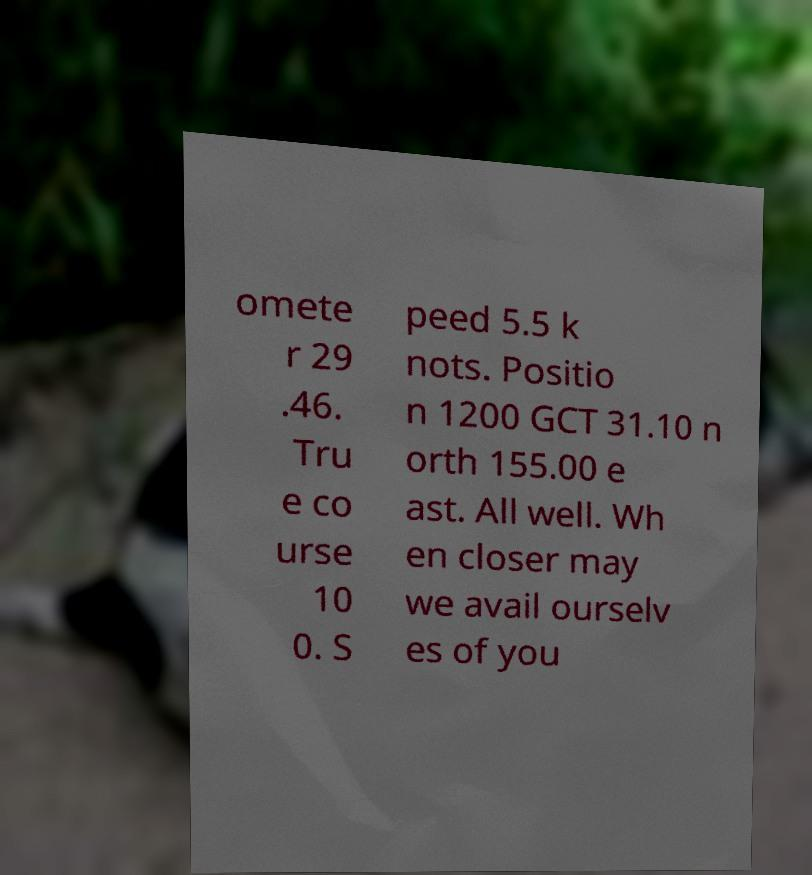There's text embedded in this image that I need extracted. Can you transcribe it verbatim? omete r 29 .46. Tru e co urse 10 0. S peed 5.5 k nots. Positio n 1200 GCT 31.10 n orth 155.00 e ast. All well. Wh en closer may we avail ourselv es of you 